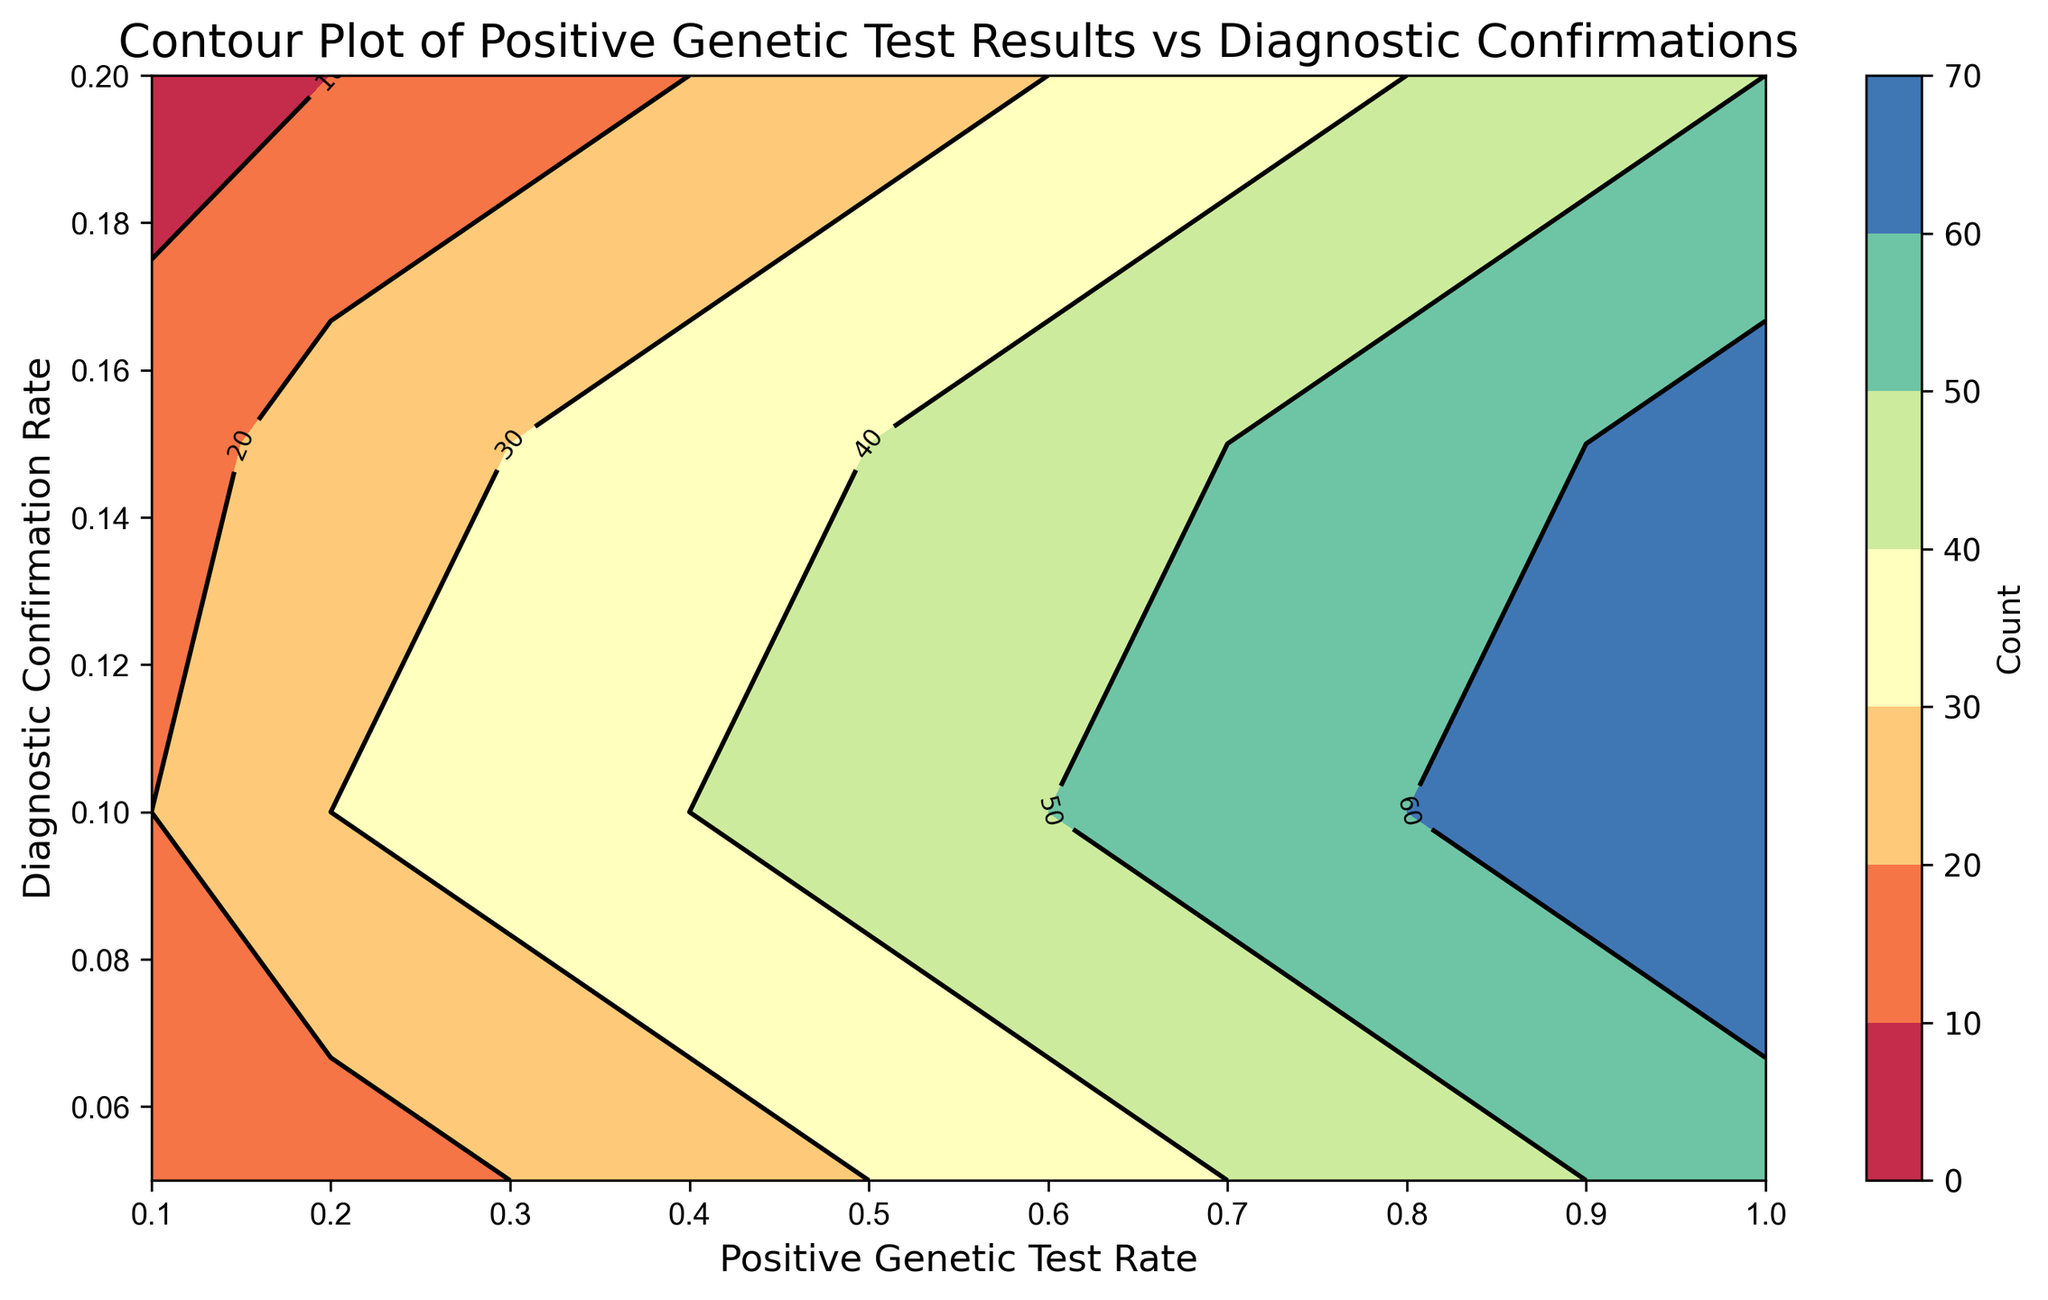What is the count of cases when the Positive Genetic Test Rate is 0.9 and the Diagnostic Confirmation Rate is 0.2? To find the count, locate the intersection of the Positive Genetic Test Rate at 0.9 on the x-axis and the Diagnostic Confirmation Rate at 0.2 on the y-axis, and then refer to the corresponding contour label or color.
Answer: 45 Which Positive Genetic Test Rate and Diagnostic Confirmation Rate have the highest count? Observe the contour plot, and find the region with the darkest color or highest contour label, then match it with the corresponding rate values on the axes.
Answer: Positive Genetic Test Rate: 1.0; Diagnostic Confirmation Rate: 0.1 When the Positive Genetic Test Rate is 0.6, which Diagnostic Confirmation Rate has the least count? Focus on the contour line corresponding to the Positive Genetic Test Rate at 0.6, then identify the lightest color or smallest contour label on the y-axis for the Diagnostic Confirmation Rate.
Answer: 0.05 Compare the count for a Positive Genetic Test Rate of 0.4 and Diagnostic Confirmation Rate of 0.15 with that for Positive Genetic Test Rate of 0.8 and Diagnostic Confirmation Rate of 0.15. Which is higher? Locate both sets of rates on the plot and compare the contour labels or color intensities at both intersections.
Answer: 0.8 and 0.15 has a higher count What is the sum of counts for Positive Genetic Test Rate 0.5 across all Diagnostic Confirmation Rates? Identify all contours for Positive Genetic Test Rate at 0.5, sum their associated counts: 0.05 (30) + 0.1 (45) + 0.15 (40) + 0.2 (25).
Answer: 140 What is the difference in the count between Positive Genetic Test Rate of 0.7 and 0.1 for Diagnostic Confirmation Rate of 0.1? Compare the counts at the given points by referring to the contour labels or colors, and calculate the difference: 55 - 20.
Answer: 35 If the Diagnostic Confirmation Rate increases from 0.05 to 0.2 while the Positive Genetic Test Rate is fixed at 0.3, how does the count trend? Observe the contour range for Positive Genetic Test Rate at 0.3 as the Diagnostic Confirmation Rate changes from 0.05 to 0.2; note how the contour labels or colors change.
Answer: Increases Which Diagnostic Confirmation Rate shows an increasing trend in count when the Positive Genetic Test Rate changes from 0.1 to 1.0? Identify the contour pattern for a fixed Diagnostic Confirmation Rate, and observe the change in contour labels or colors as Positive Genetic Test Rate increases from 0.1 to 1.0. The Diagnostic Confirmation Rate with consistently increasing contour labels is desired.
Answer: 0.1 At which Diagnostic Confirmation Rate is the count lowest across all Positive Genetic Test Rates? Review all diagonal counts on the contour plot, identify the line with consistently light colors or low contour labels.
Answer: 0.05 What is the average count for Positive Genetic Test Rate 0.3 across all Diagnostic Confirmation Rates? Sum the counts for Positive Genetic Test Rate at 0.3 across all Diagnostic Confirmation Rates: 0.05 (20) + 0.1 (35) + 0.15 (30) + 0.2 (15), then divide by the number of rates (4).
Answer: 25 